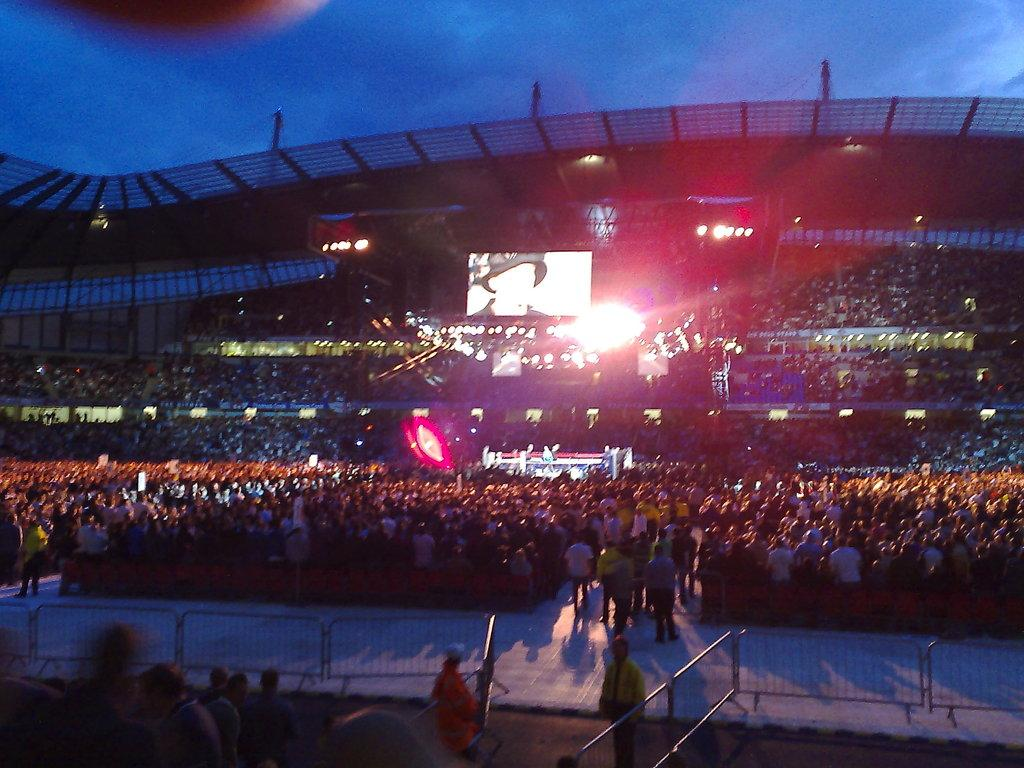What type of location is depicted in the image? There is a concert-like place in the image. Are there any people present in the image? Yes, there are people in the image. What can be seen in terms of lighting in the image? There are lights in the image. What kind of display is present in the image? There is a projector screen in the image. Can you tell me how many monkeys are performing on the projector screen in the image? There are no monkeys present in the image, and therefore no such performance can be observed on the projector screen. 